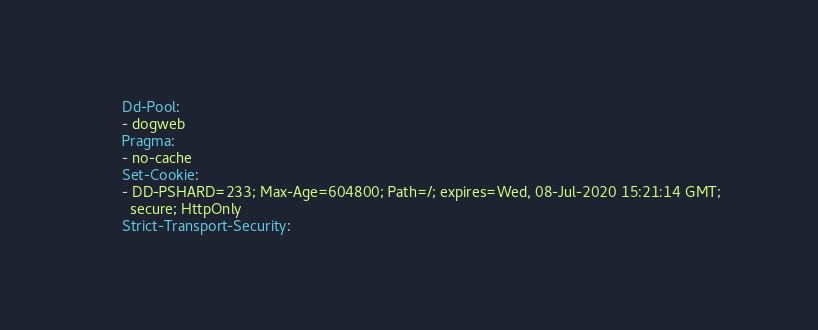Convert code to text. <code><loc_0><loc_0><loc_500><loc_500><_YAML_>      Dd-Pool:
      - dogweb
      Pragma:
      - no-cache
      Set-Cookie:
      - DD-PSHARD=233; Max-Age=604800; Path=/; expires=Wed, 08-Jul-2020 15:21:14 GMT;
        secure; HttpOnly
      Strict-Transport-Security:</code> 